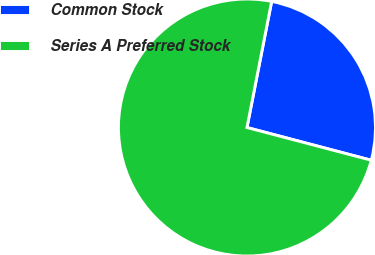<chart> <loc_0><loc_0><loc_500><loc_500><pie_chart><fcel>Common Stock<fcel>Series A Preferred Stock<nl><fcel>26.02%<fcel>73.98%<nl></chart> 